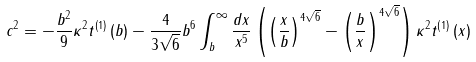Convert formula to latex. <formula><loc_0><loc_0><loc_500><loc_500>c ^ { 2 } = - \frac { b ^ { 2 } } { 9 } \kappa ^ { 2 } t ^ { \left ( 1 \right ) } \left ( b \right ) - \frac { 4 } { 3 \sqrt { 6 } } b ^ { 6 } \int ^ { \infty } _ { b } \frac { d x } { x ^ { 5 } } \left ( \left ( \frac { x } { b } \right ) ^ { 4 \sqrt { 6 } } - \left ( \frac { b } { x } \right ) ^ { 4 \sqrt { 6 } } \right ) \kappa ^ { 2 } t ^ { \left ( 1 \right ) } \left ( x \right )</formula> 